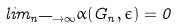<formula> <loc_0><loc_0><loc_500><loc_500>l i m _ { n \longrightarrow \infty } \alpha ( G _ { n } , \epsilon ) = 0</formula> 